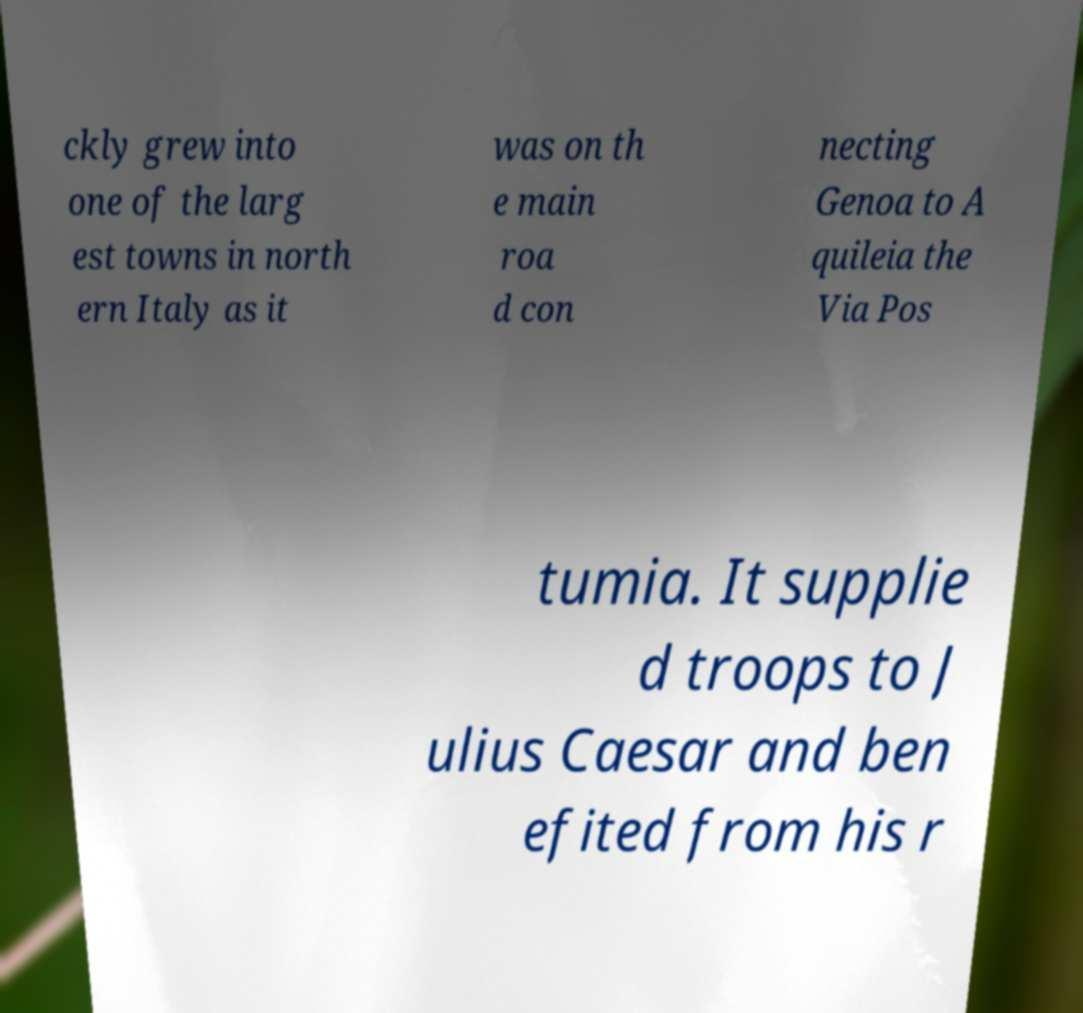Please read and relay the text visible in this image. What does it say? ckly grew into one of the larg est towns in north ern Italy as it was on th e main roa d con necting Genoa to A quileia the Via Pos tumia. It supplie d troops to J ulius Caesar and ben efited from his r 